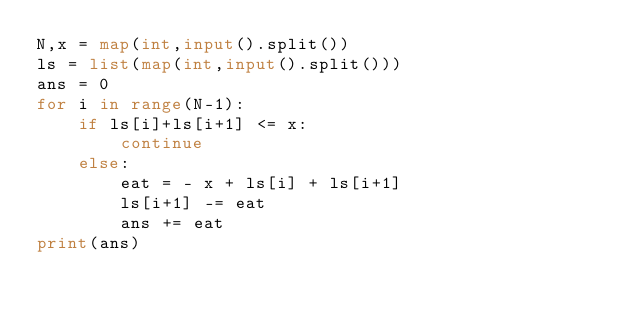<code> <loc_0><loc_0><loc_500><loc_500><_Python_>N,x = map(int,input().split())
ls = list(map(int,input().split()))
ans = 0
for i in range(N-1):
    if ls[i]+ls[i+1] <= x:
        continue
    else:
        eat = - x + ls[i] + ls[i+1]
        ls[i+1] -= eat
        ans += eat
print(ans)</code> 